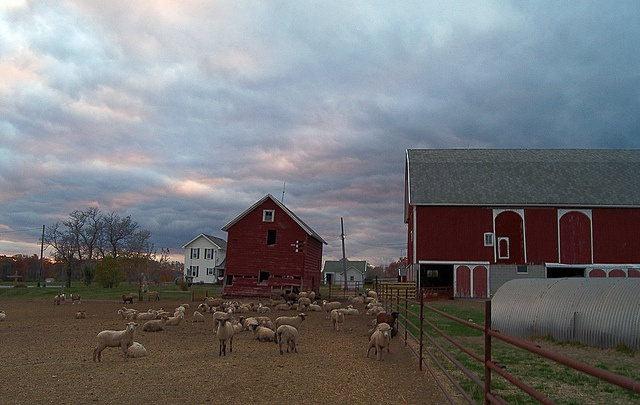Describe the objects in this image and their specific colors. I can see sheep in white, maroon, black, and gray tones, sheep in white, black, and gray tones, sheep in white, black, maroon, and gray tones, sheep in white, black, and gray tones, and sheep in white, black, maroon, and gray tones in this image. 